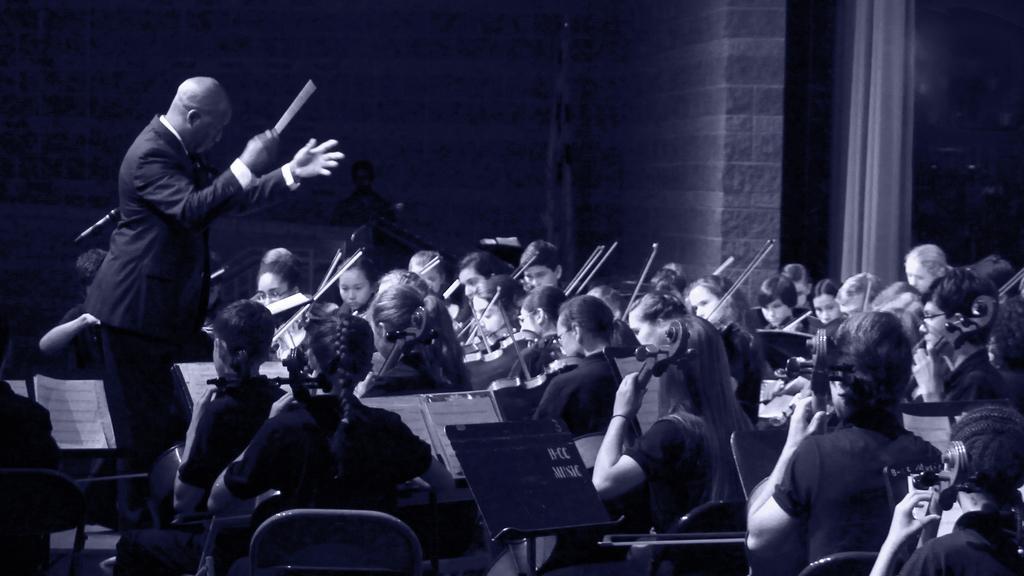Describe this image in one or two sentences. This is the picture of a place where we have some people sitting on chairs and playing some musical instruments and also we can see a person who is holding the stick. 